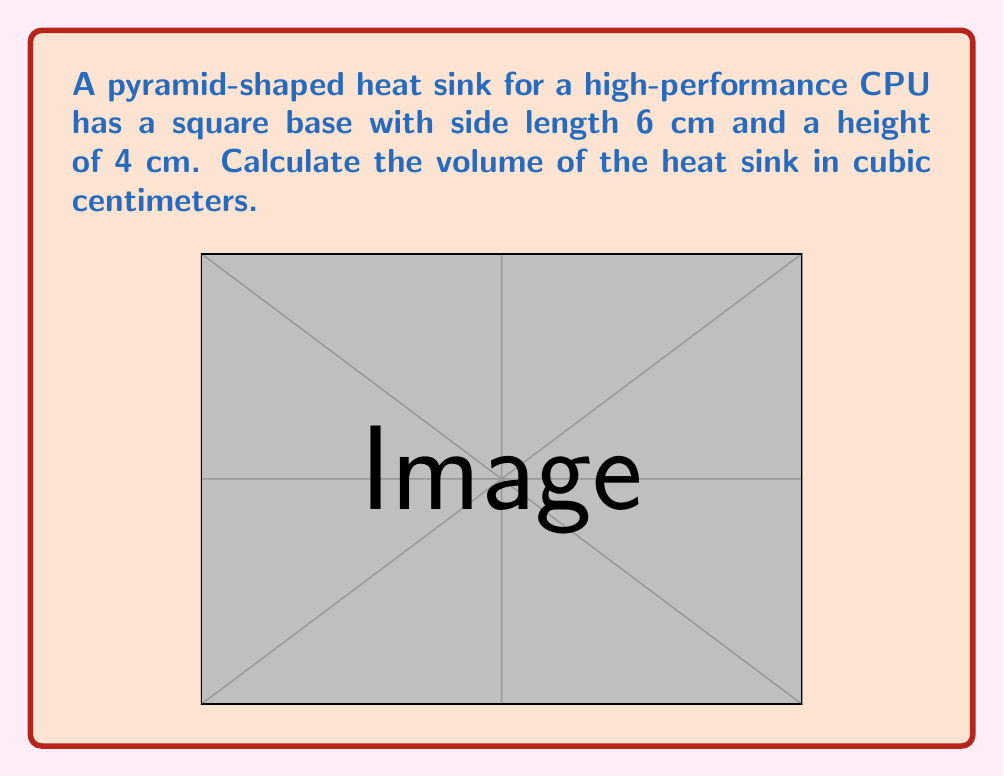Can you solve this math problem? To calculate the volume of a pyramid, we use the formula:

$$V = \frac{1}{3} \times B \times h$$

Where:
$V$ = volume
$B$ = area of the base
$h$ = height of the pyramid

Step 1: Calculate the area of the square base
The base is a square with side length 6 cm.
$B = 6 \text{ cm} \times 6 \text{ cm} = 36 \text{ cm}^2$

Step 2: Use the volume formula
$V = \frac{1}{3} \times B \times h$
$V = \frac{1}{3} \times 36 \text{ cm}^2 \times 4 \text{ cm}$

Step 3: Simplify and calculate
$V = \frac{1}{3} \times 144 \text{ cm}^3 = 48 \text{ cm}^3$

Therefore, the volume of the pyramid-shaped heat sink is 48 cubic centimeters.
Answer: $48 \text{ cm}^3$ 